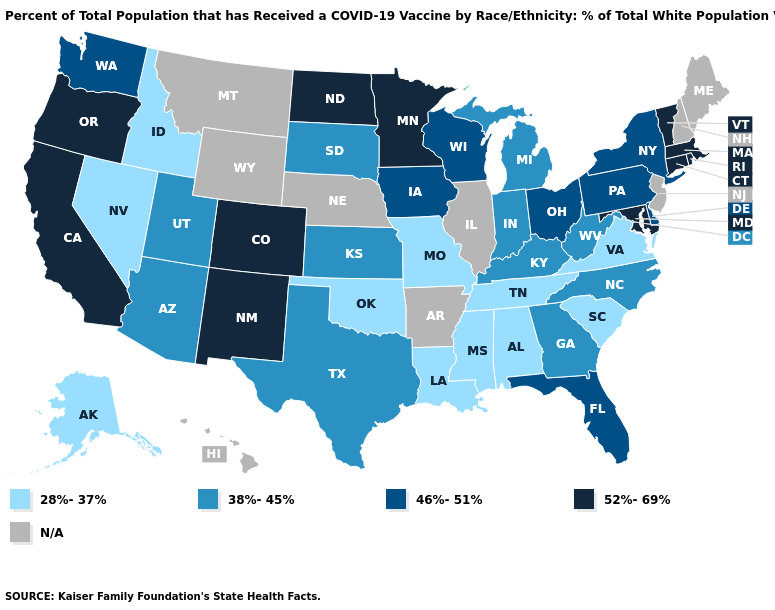Name the states that have a value in the range 52%-69%?
Give a very brief answer. California, Colorado, Connecticut, Maryland, Massachusetts, Minnesota, New Mexico, North Dakota, Oregon, Rhode Island, Vermont. What is the value of Kansas?
Quick response, please. 38%-45%. What is the lowest value in the USA?
Short answer required. 28%-37%. What is the value of Virginia?
Concise answer only. 28%-37%. Does the first symbol in the legend represent the smallest category?
Concise answer only. Yes. Which states hav the highest value in the MidWest?
Answer briefly. Minnesota, North Dakota. Name the states that have a value in the range 52%-69%?
Write a very short answer. California, Colorado, Connecticut, Maryland, Massachusetts, Minnesota, New Mexico, North Dakota, Oregon, Rhode Island, Vermont. Among the states that border Nevada , which have the highest value?
Give a very brief answer. California, Oregon. Name the states that have a value in the range 28%-37%?
Short answer required. Alabama, Alaska, Idaho, Louisiana, Mississippi, Missouri, Nevada, Oklahoma, South Carolina, Tennessee, Virginia. Among the states that border Alabama , which have the lowest value?
Keep it brief. Mississippi, Tennessee. Name the states that have a value in the range 52%-69%?
Write a very short answer. California, Colorado, Connecticut, Maryland, Massachusetts, Minnesota, New Mexico, North Dakota, Oregon, Rhode Island, Vermont. How many symbols are there in the legend?
Be succinct. 5. What is the lowest value in the USA?
Short answer required. 28%-37%. 